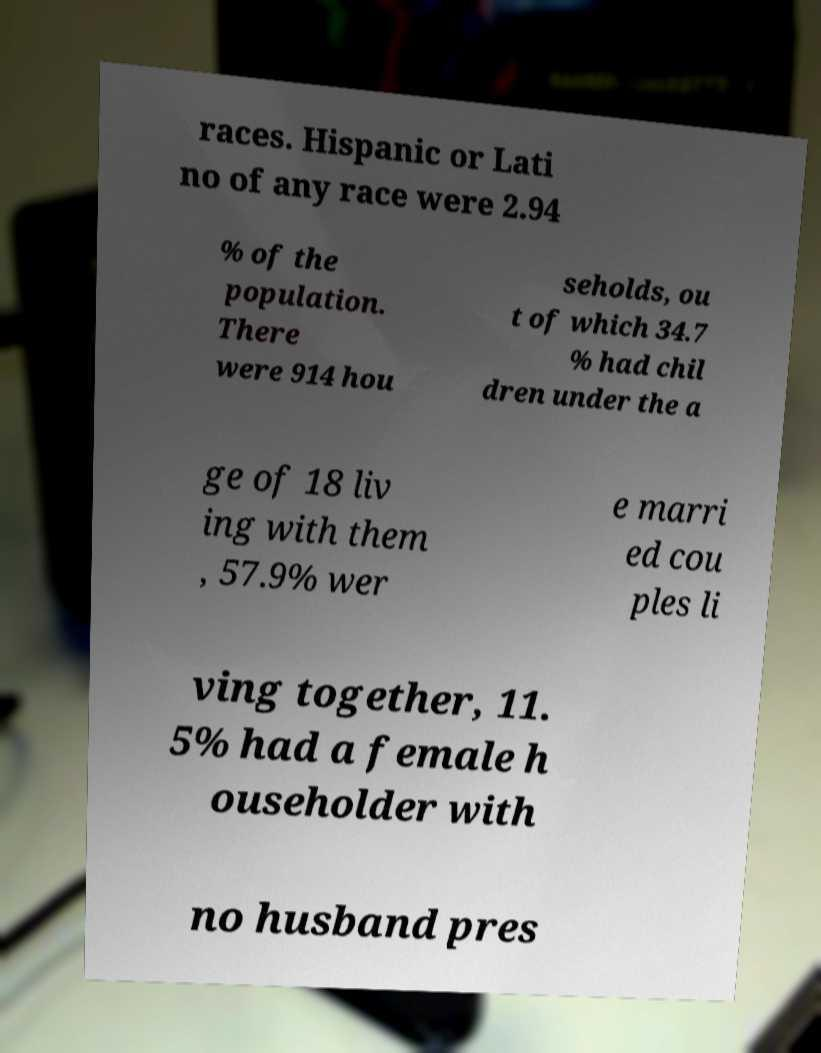For documentation purposes, I need the text within this image transcribed. Could you provide that? races. Hispanic or Lati no of any race were 2.94 % of the population. There were 914 hou seholds, ou t of which 34.7 % had chil dren under the a ge of 18 liv ing with them , 57.9% wer e marri ed cou ples li ving together, 11. 5% had a female h ouseholder with no husband pres 